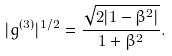Convert formula to latex. <formula><loc_0><loc_0><loc_500><loc_500>| g ^ { ( 3 ) } | ^ { 1 / 2 } = \frac { \sqrt { 2 | 1 - \beta ^ { 2 } | } } { 1 + \beta ^ { 2 } } .</formula> 